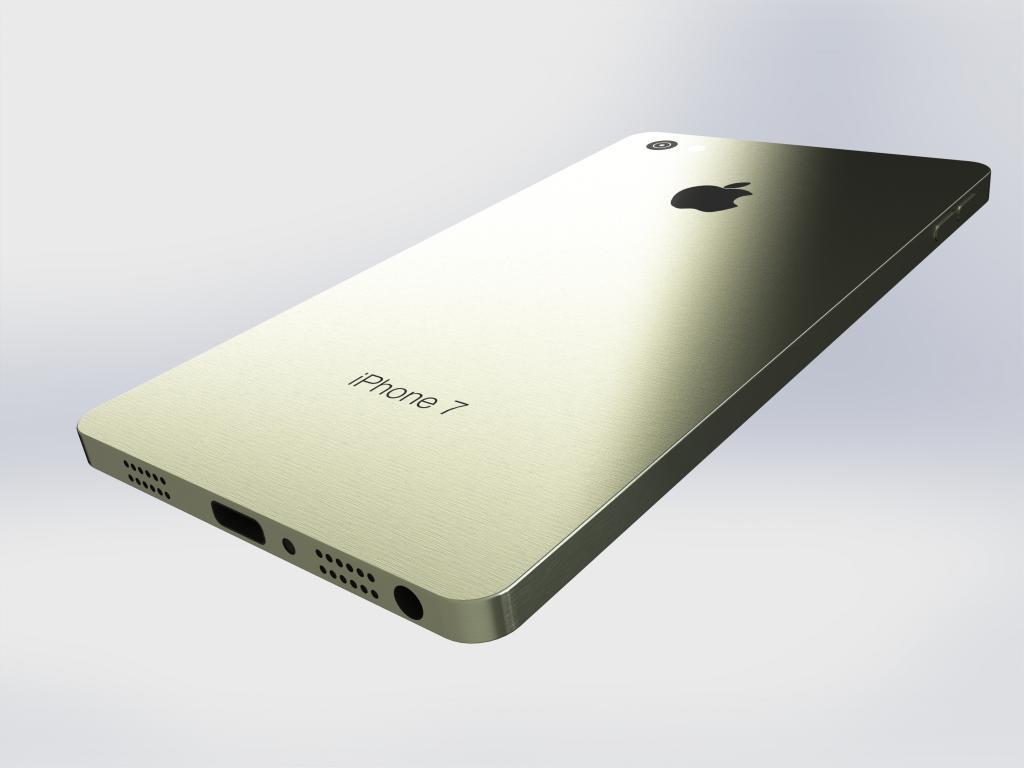<image>
Describe the image concisely. Back of a cellphone that says the words iPhone 7 on it. 